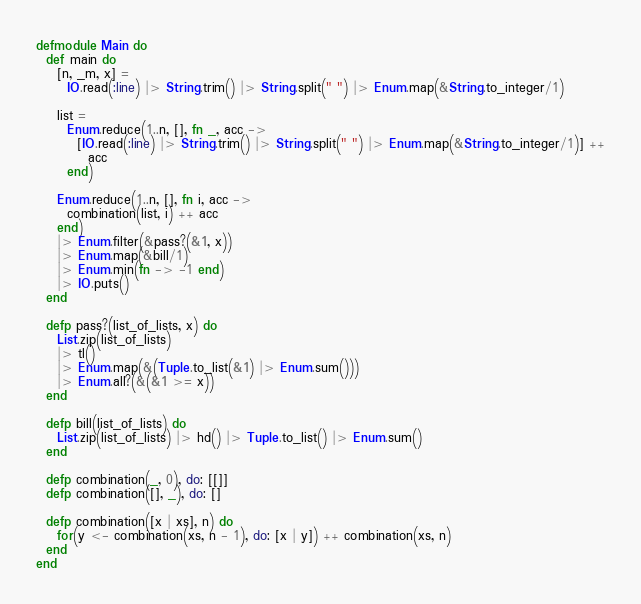<code> <loc_0><loc_0><loc_500><loc_500><_Elixir_>defmodule Main do
  def main do
    [n, _m, x] =
      IO.read(:line) |> String.trim() |> String.split(" ") |> Enum.map(&String.to_integer/1)

    list =
      Enum.reduce(1..n, [], fn _, acc ->
        [IO.read(:line) |> String.trim() |> String.split(" ") |> Enum.map(&String.to_integer/1)] ++
          acc
      end)

    Enum.reduce(1..n, [], fn i, acc ->
      combination(list, i) ++ acc
    end)
    |> Enum.filter(&pass?(&1, x))
    |> Enum.map(&bill/1)
    |> Enum.min(fn -> -1 end)
    |> IO.puts()
  end

  defp pass?(list_of_lists, x) do
    List.zip(list_of_lists)
    |> tl()
    |> Enum.map(&(Tuple.to_list(&1) |> Enum.sum()))
    |> Enum.all?(&(&1 >= x))
  end

  defp bill(list_of_lists) do
    List.zip(list_of_lists) |> hd() |> Tuple.to_list() |> Enum.sum()
  end

  defp combination(_, 0), do: [[]]
  defp combination([], _), do: []

  defp combination([x | xs], n) do
    for(y <- combination(xs, n - 1), do: [x | y]) ++ combination(xs, n)
  end
end
</code> 